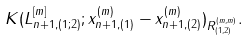<formula> <loc_0><loc_0><loc_500><loc_500>K ( L ^ { [ m ] } _ { n + 1 , ( 1 ; 2 ) } ; x _ { n + 1 , ( 1 ) } ^ { ( m ) } - x _ { n + 1 , ( 2 ) } ^ { ( m ) } ) _ { R _ { ( 1 , 2 ) } ^ { ( m , m ) } } .</formula> 